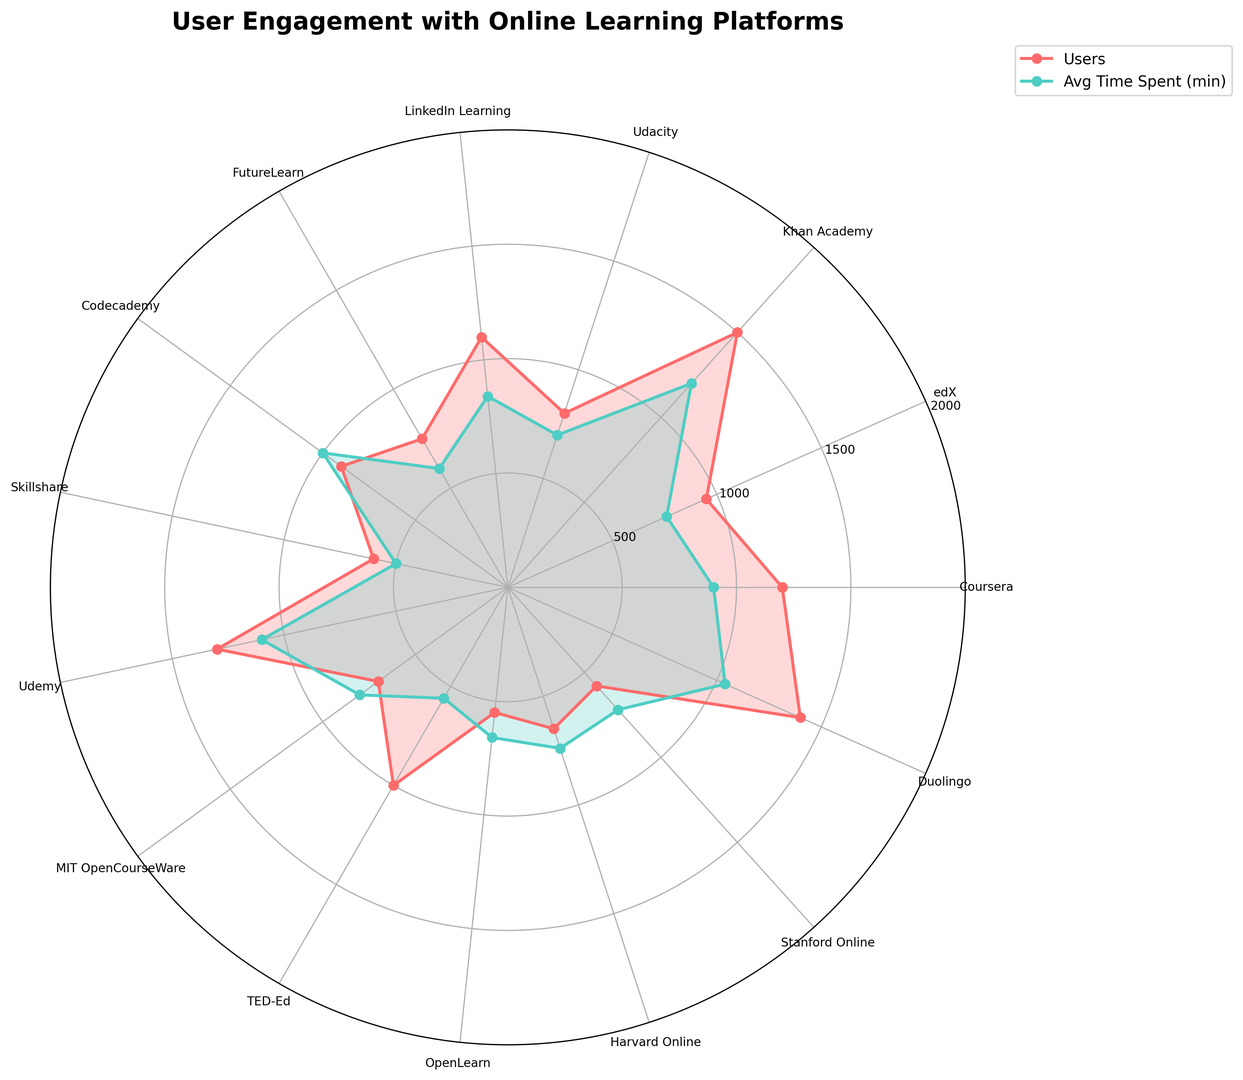Which platform has the highest number of users? By examining the lengths of the plots in the rose chart, the platform with the longest plot line among "Users" is Khan Academy.
Answer: Khan Academy Which platform has the lowest average time spent? The plot with the smallest radius for "Avg Time Spent (min)" is Skillshare, indicated by the green-colored plot lines.
Answer: Skillshare How many more users does Duolingo have compared to LinkedIn Learning? Duolingo has 1400 users, and LinkedIn Learning has 1100 users. The difference is 1400 - 1100 = 300 users.
Answer: 300 What is the average time spent on Coursera compared to Udemy? Coursera has around 45 minutes, and Udemy has around 55 minutes.
Answer: Coursera: 45 minutes, Udemy: 55 minutes Which platform shows the highest average time spent per user? Visually, the plot line for "Avg Time Spent (min)" is the longest, indicating Khan Academy.
Answer: Khan Academy Are there any platforms where the number of users and the average time spent both lie above the median? The median number of users is 900. Platforms above that in both categories (users and time) are Khan Academy, Duolingo, and Udemy.
Answer: Khan Academy, Duolingo, Udemy Is the average time spent on Duolingo greater than on Codecademy? The radius for "Avg Time Spent (min)" line for Duolingo is larger than that for Codecademy. Duolingo's average time is 52 minutes compared to Codecademy's 50 minutes.
Answer: Yes How does the user engagement of Harvard Online compare to Stanford Online in terms of users and average time? Harvard Online has 650 users and 37 minutes of average time. Stanford Online has 580 users and 36 minutes of average time, making Harvard slightly higher in both metrics.
Answer: Harvard Online has higher engagement Calculate the total number of users for LinkedIn Learning, TED-Ed, and eDX combined. Summing the users: LinkedIn Learning = 1100, TED-Ed = 1000, eDX = 950. Thus, 1100 + 1000 + 950 = 3050.
Answer: 3050 Compare the difference in average time spent between OpenLearn and FutureLearn. OpenLearn has an average time of 33 minutes, while FutureLearn has 30 minutes. The difference is 33 - 30 = 3 minutes.
Answer: 3 minutes 